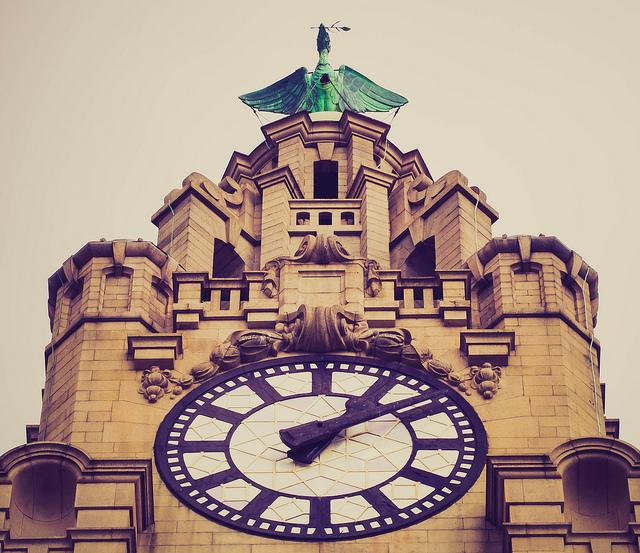What time is shown on the clock?
Keep it brief. 1:10. What color is the bird statue?
Short answer required. Green. What time is it on the clock?
Quick response, please. 1:10. What does the bird statue have in its mouth?
Answer briefly. Flower. 